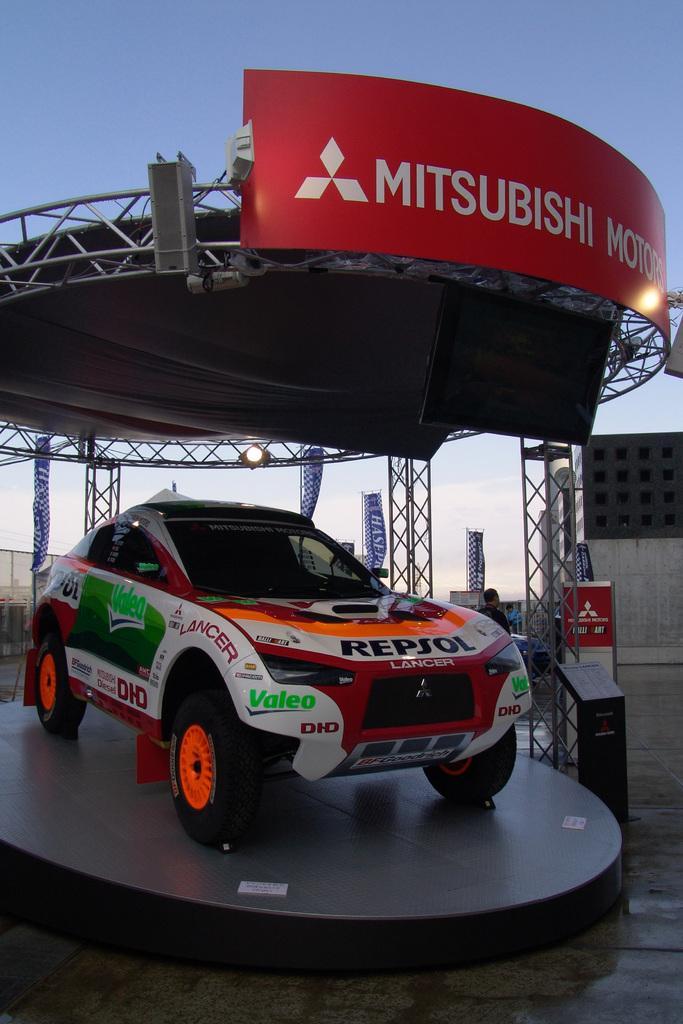Could you give a brief overview of what you see in this image? In this picture we can see a car on a platform and in the background we can see a roof, person, banners, name boards, shed, stands, sky. 